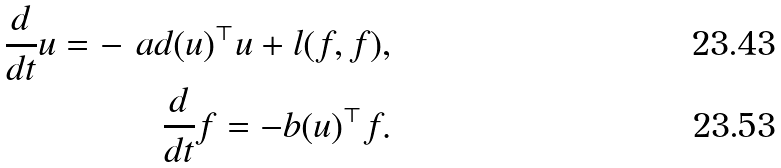Convert formula to latex. <formula><loc_0><loc_0><loc_500><loc_500>\frac { d } { d t } u = - \ a d ( u ) ^ { \top } u + l ( f , f ) , \\ \frac { d } { d t } f = - b ( u ) ^ { \top } f .</formula> 